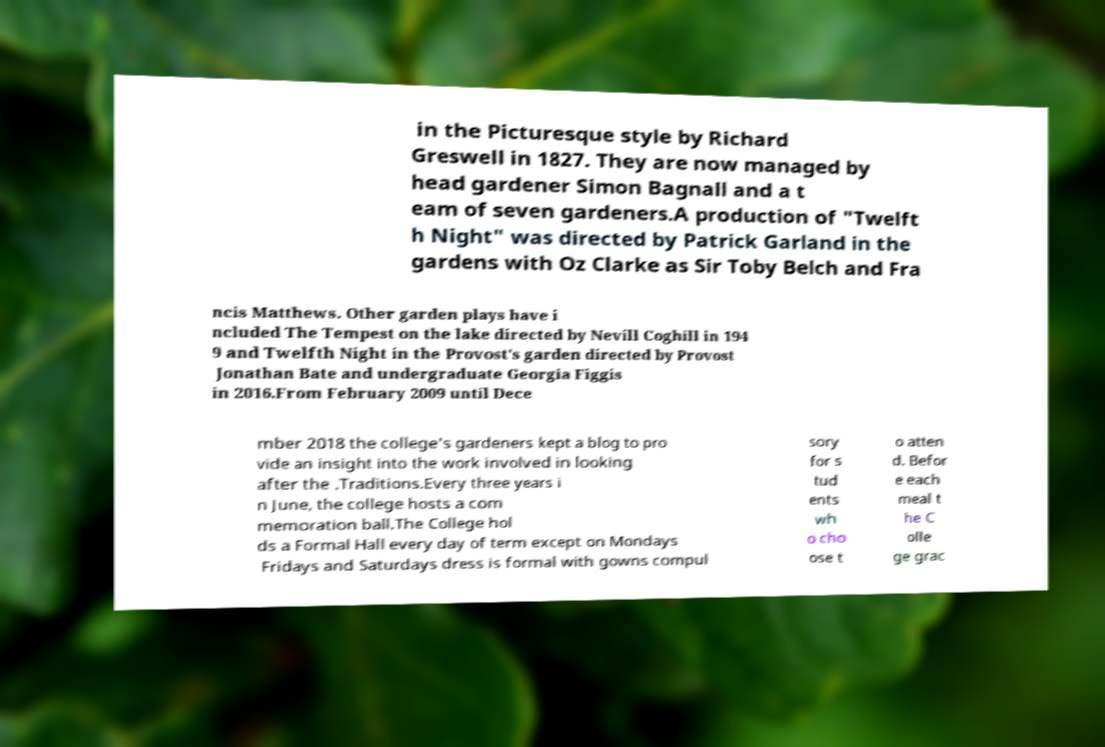Please read and relay the text visible in this image. What does it say? in the Picturesque style by Richard Greswell in 1827. They are now managed by head gardener Simon Bagnall and a t eam of seven gardeners.A production of "Twelft h Night" was directed by Patrick Garland in the gardens with Oz Clarke as Sir Toby Belch and Fra ncis Matthews. Other garden plays have i ncluded The Tempest on the lake directed by Nevill Coghill in 194 9 and Twelfth Night in the Provost's garden directed by Provost Jonathan Bate and undergraduate Georgia Figgis in 2016.From February 2009 until Dece mber 2018 the college's gardeners kept a blog to pro vide an insight into the work involved in looking after the .Traditions.Every three years i n June, the college hosts a com memoration ball.The College hol ds a Formal Hall every day of term except on Mondays Fridays and Saturdays dress is formal with gowns compul sory for s tud ents wh o cho ose t o atten d. Befor e each meal t he C olle ge grac 